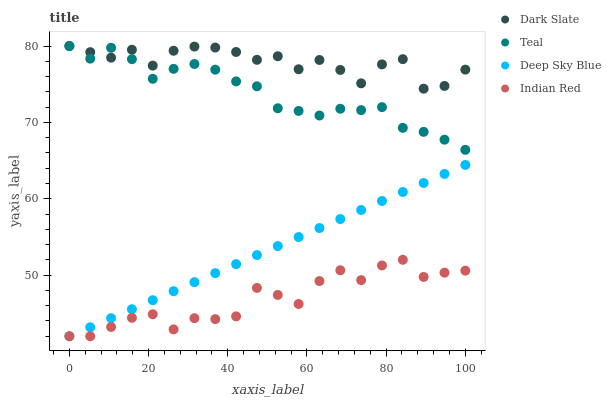Does Indian Red have the minimum area under the curve?
Answer yes or no. Yes. Does Dark Slate have the maximum area under the curve?
Answer yes or no. Yes. Does Deep Sky Blue have the minimum area under the curve?
Answer yes or no. No. Does Deep Sky Blue have the maximum area under the curve?
Answer yes or no. No. Is Deep Sky Blue the smoothest?
Answer yes or no. Yes. Is Dark Slate the roughest?
Answer yes or no. Yes. Is Dark Slate the smoothest?
Answer yes or no. No. Is Deep Sky Blue the roughest?
Answer yes or no. No. Does Indian Red have the lowest value?
Answer yes or no. Yes. Does Dark Slate have the lowest value?
Answer yes or no. No. Does Teal have the highest value?
Answer yes or no. Yes. Does Deep Sky Blue have the highest value?
Answer yes or no. No. Is Indian Red less than Dark Slate?
Answer yes or no. Yes. Is Dark Slate greater than Deep Sky Blue?
Answer yes or no. Yes. Does Teal intersect Dark Slate?
Answer yes or no. Yes. Is Teal less than Dark Slate?
Answer yes or no. No. Is Teal greater than Dark Slate?
Answer yes or no. No. Does Indian Red intersect Dark Slate?
Answer yes or no. No. 